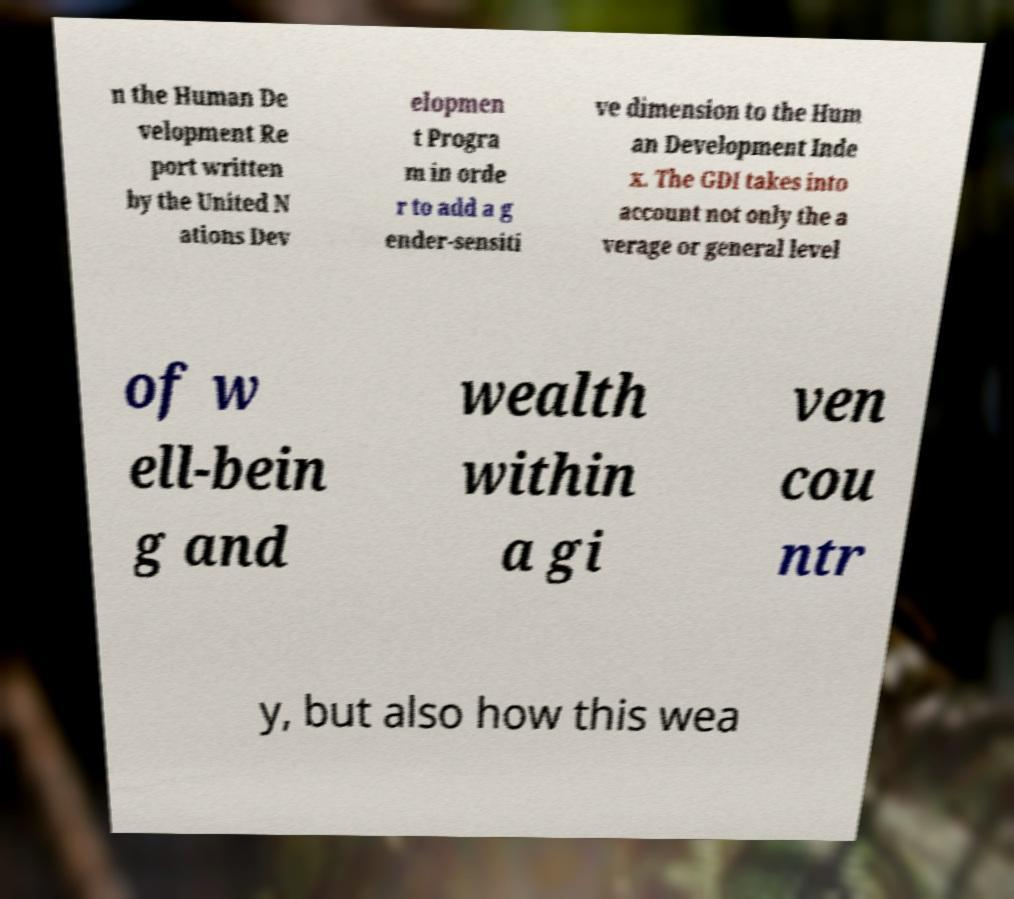Could you extract and type out the text from this image? n the Human De velopment Re port written by the United N ations Dev elopmen t Progra m in orde r to add a g ender-sensiti ve dimension to the Hum an Development Inde x. The GDI takes into account not only the a verage or general level of w ell-bein g and wealth within a gi ven cou ntr y, but also how this wea 